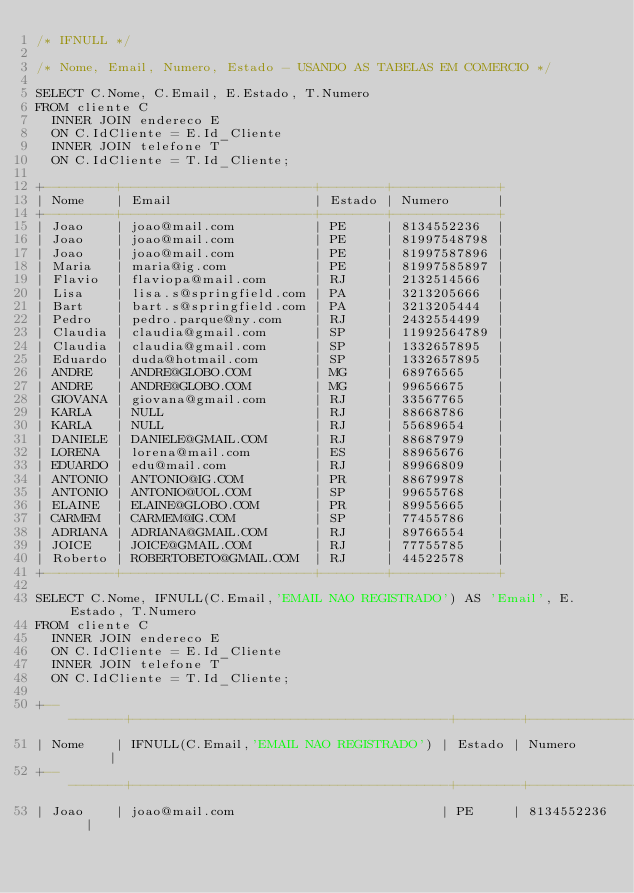Convert code to text. <code><loc_0><loc_0><loc_500><loc_500><_SQL_>/* IFNULL */

/* Nome, Email, Numero, Estado - USANDO AS TABELAS EM COMERCIO */

SELECT C.Nome, C.Email, E.Estado, T.Numero
FROM cliente C
	INNER JOIN endereco E
	ON C.IdCliente = E.Id_Cliente
	INNER JOIN telefone T
	ON C.IdCliente = T.Id_Cliente;

+---------+------------------------+--------+-------------+
| Nome    | Email                  | Estado | Numero      |
+---------+------------------------+--------+-------------+
| Joao    | joao@mail.com          | PE     | 8134552236  |
| Joao    | joao@mail.com          | PE     | 81997548798 |
| Joao    | joao@mail.com          | PE     | 81997587896 |
| Maria   | maria@ig.com           | PE     | 81997585897 |
| Flavio  | flaviopa@mail.com      | RJ     | 2132514566  |
| Lisa    | lisa.s@springfield.com | PA     | 3213205666  |
| Bart    | bart.s@springfield.com | PA     | 3213205444  |
| Pedro   | pedro.parque@ny.com    | RJ     | 2432554499  |
| Claudia | claudia@gmail.com      | SP     | 11992564789 |
| Claudia | claudia@gmail.com      | SP     | 1332657895  |
| Eduardo | duda@hotmail.com       | SP     | 1332657895  |
| ANDRE   | ANDRE@GLOBO.COM        | MG     | 68976565    |
| ANDRE   | ANDRE@GLOBO.COM        | MG     | 99656675    |
| GIOVANA | giovana@gmail.com      | RJ     | 33567765    |
| KARLA   | NULL                   | RJ     | 88668786    |
| KARLA   | NULL                   | RJ     | 55689654    |
| DANIELE | DANIELE@GMAIL.COM      | RJ     | 88687979    |
| LORENA  | lorena@mail.com        | ES     | 88965676    |
| EDUARDO | edu@mail.com           | RJ     | 89966809    |
| ANTONIO | ANTONIO@IG.COM         | PR     | 88679978    |
| ANTONIO | ANTONIO@UOL.COM        | SP     | 99655768    |
| ELAINE  | ELAINE@GLOBO.COM       | PR     | 89955665    |
| CARMEM  | CARMEM@IG.COM          | SP     | 77455786    |
| ADRIANA | ADRIANA@GMAIL.COM      | RJ     | 89766554    |
| JOICE   | JOICE@GMAIL.COM        | RJ     | 77755785    |
| Roberto | ROBERTOBETO@GMAIL.COM  | RJ     | 44522578    |
+---------+------------------------+--------+-------------+

SELECT C.Nome, IFNULL(C.Email,'EMAIL NAO REGISTRADO') AS 'Email', E.Estado, T.Numero
FROM cliente C
	INNER JOIN endereco E
	ON C.IdCliente = E.Id_Cliente
	INNER JOIN telefone T
	ON C.IdCliente = T.Id_Cliente;
	
+---------+----------------------------------------+--------+-------------+
| Nome    | IFNULL(C.Email,'EMAIL NAO REGISTRADO') | Estado | Numero      |
+---------+----------------------------------------+--------+-------------+
| Joao    | joao@mail.com                          | PE     | 8134552236  |</code> 